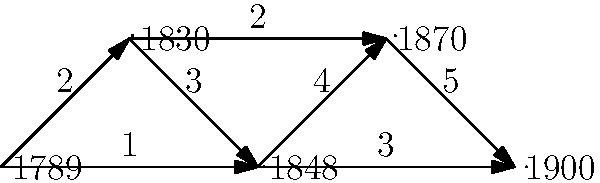In the temporal graph representing the connectivity of anti-monarchist groups from 1789 to 1900, what is the maximum number of distinct paths between the nodes representing 1789 and 1900, considering the edge weights as years of sustained connection? To solve this problem, we need to analyze the graph and count the number of distinct paths from 1789 to 1900, considering the edge weights. Let's break it down step-by-step:

1. Identify possible paths:
   Path 1: 1789 -> 1830 -> 1848 -> 1870 -> 1900
   Path 2: 1789 -> 1848 -> 1870 -> 1900
   Path 3: 1789 -> 1830 -> 1870 -> 1900
   Path 4: 1789 -> 1848 -> 1900

2. Calculate the total years of sustained connection for each path:
   Path 1: 2 + 3 + 4 + 5 = 14 years
   Path 2: 1 + 4 + 5 = 10 years
   Path 3: 2 + 2 + 5 = 9 years
   Path 4: 1 + 3 = 4 years

3. Count the number of distinct paths:
   There are 4 distinct paths from 1789 to 1900.

4. Verify that each path is unique in terms of the nodes it passes through or the total years of sustained connection.

Therefore, the maximum number of distinct paths between the nodes representing 1789 and 1900 is 4.
Answer: 4 